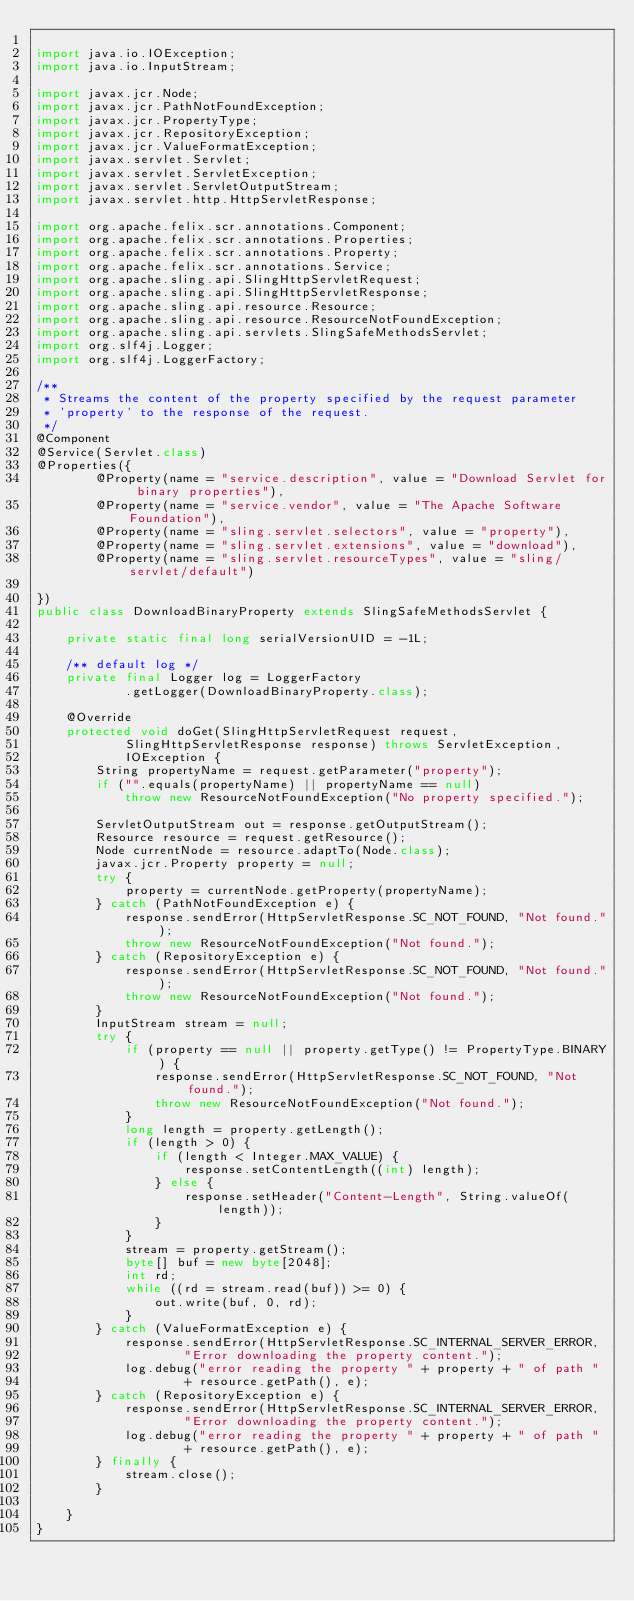<code> <loc_0><loc_0><loc_500><loc_500><_Java_>
import java.io.IOException;
import java.io.InputStream;

import javax.jcr.Node;
import javax.jcr.PathNotFoundException;
import javax.jcr.PropertyType;
import javax.jcr.RepositoryException;
import javax.jcr.ValueFormatException;
import javax.servlet.Servlet;
import javax.servlet.ServletException;
import javax.servlet.ServletOutputStream;
import javax.servlet.http.HttpServletResponse;

import org.apache.felix.scr.annotations.Component;
import org.apache.felix.scr.annotations.Properties;
import org.apache.felix.scr.annotations.Property;
import org.apache.felix.scr.annotations.Service;
import org.apache.sling.api.SlingHttpServletRequest;
import org.apache.sling.api.SlingHttpServletResponse;
import org.apache.sling.api.resource.Resource;
import org.apache.sling.api.resource.ResourceNotFoundException;
import org.apache.sling.api.servlets.SlingSafeMethodsServlet;
import org.slf4j.Logger;
import org.slf4j.LoggerFactory;

/**
 * Streams the content of the property specified by the request parameter
 * 'property' to the response of the request.
 */
@Component
@Service(Servlet.class)
@Properties({
		@Property(name = "service.description", value = "Download Servlet for binary properties"),
		@Property(name = "service.vendor", value = "The Apache Software Foundation"),
		@Property(name = "sling.servlet.selectors", value = "property"),
		@Property(name = "sling.servlet.extensions", value = "download"),
		@Property(name = "sling.servlet.resourceTypes", value = "sling/servlet/default")

})
public class DownloadBinaryProperty extends SlingSafeMethodsServlet {

	private static final long serialVersionUID = -1L;

	/** default log */
	private final Logger log = LoggerFactory
			.getLogger(DownloadBinaryProperty.class);

	@Override
	protected void doGet(SlingHttpServletRequest request,
			SlingHttpServletResponse response) throws ServletException,
			IOException {
		String propertyName = request.getParameter("property");
		if ("".equals(propertyName) || propertyName == null)
			throw new ResourceNotFoundException("No property specified.");

		ServletOutputStream out = response.getOutputStream();
		Resource resource = request.getResource();
		Node currentNode = resource.adaptTo(Node.class);
		javax.jcr.Property property = null;
		try {
			property = currentNode.getProperty(propertyName);
		} catch (PathNotFoundException e) {
			response.sendError(HttpServletResponse.SC_NOT_FOUND, "Not found.");
			throw new ResourceNotFoundException("Not found.");
		} catch (RepositoryException e) {
			response.sendError(HttpServletResponse.SC_NOT_FOUND, "Not found.");
			throw new ResourceNotFoundException("Not found.");
		}
		InputStream stream = null;
		try {
			if (property == null || property.getType() != PropertyType.BINARY) {
				response.sendError(HttpServletResponse.SC_NOT_FOUND, "Not found.");
				throw new ResourceNotFoundException("Not found.");
			}
			long length = property.getLength();
			if (length > 0) {
				if (length < Integer.MAX_VALUE) {
					response.setContentLength((int) length);
				} else {
					response.setHeader("Content-Length", String.valueOf(length));
				}
			}
			stream = property.getStream();
			byte[] buf = new byte[2048];
			int rd;
			while ((rd = stream.read(buf)) >= 0) {
				out.write(buf, 0, rd);
			}
		} catch (ValueFormatException e) {
			response.sendError(HttpServletResponse.SC_INTERNAL_SERVER_ERROR,
					"Error downloading the property content.");
			log.debug("error reading the property " + property + " of path "
					+ resource.getPath(), e);
		} catch (RepositoryException e) {
			response.sendError(HttpServletResponse.SC_INTERNAL_SERVER_ERROR,
					"Error downloading the property content.");
			log.debug("error reading the property " + property + " of path "
					+ resource.getPath(), e);
		} finally {
			stream.close();
		}

	}
}</code> 